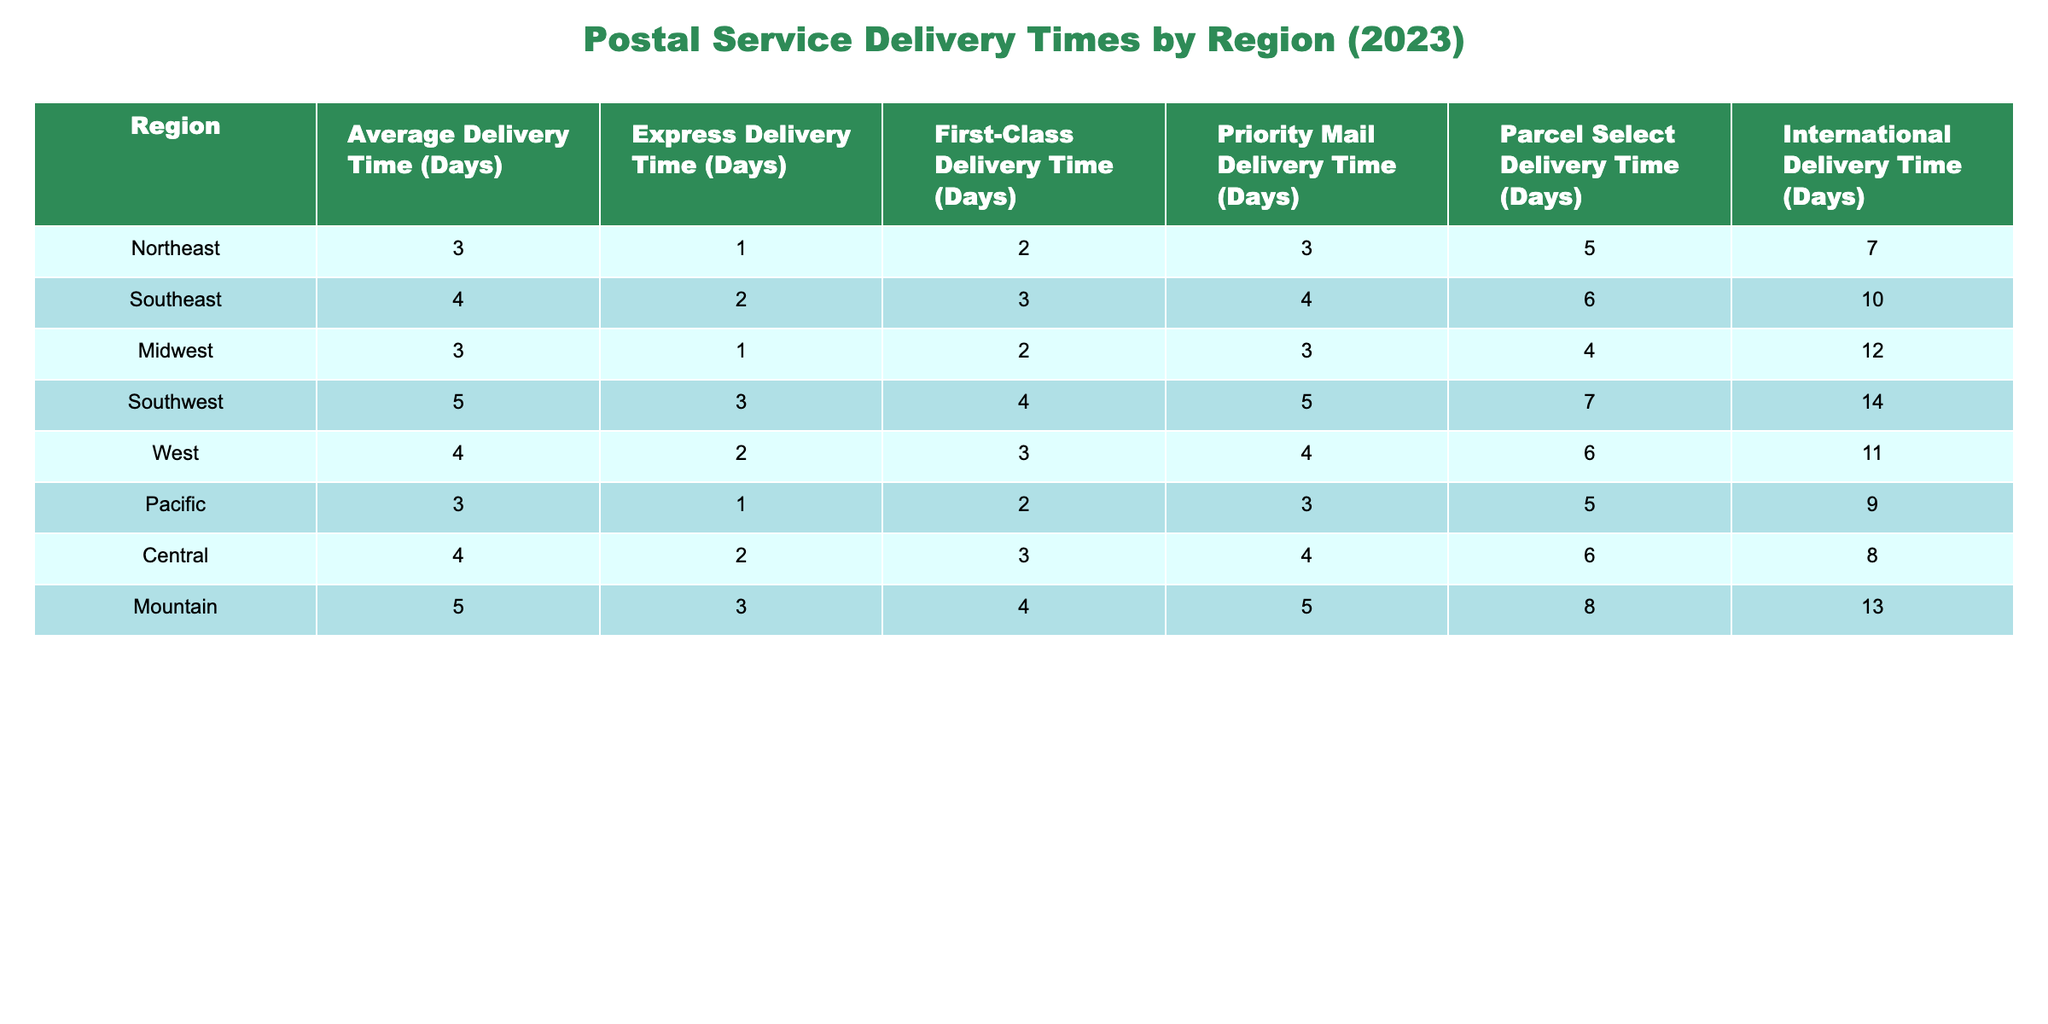What is the average delivery time in the Northeast region? The average delivery time for the Northeast region is directly found in the table under "Average Delivery Time (Days)" for that region, which is listed as 3 days.
Answer: 3 days Which region has the shortest express delivery time? To find the shortest express delivery time, we look at the "Express Delivery Time (Days)" column and identify the minimum value among the regions. The shortest time is 1 day, which occurs in three regions: Northeast, Midwest, and Pacific.
Answer: 1 day What is the difference between the average delivery time in the Southwest and the Pacific regions? The average delivery time in the Southwest is 5 days, and in the Pacific is 3 days. The difference is calculated by subtracting Pacific's time from Southwest's: 5 - 3 = 2.
Answer: 2 days Which region has the longest International delivery time and what is that time? To determine this, we check the "International Delivery Time (Days)" column for all regions and find that the Southwest region has the longest delivery time of 14 days.
Answer: Southwest has 14 days How many days is the first-class delivery time in the Southeast longer than in the Midwest? We compare their first-class delivery times: Southeast has 3 days, and Midwest has 2 days. The difference is 3 - 2 = 1 day.
Answer: 1 day Is the express delivery time in the Central region less than or equal to 2 days? Looking at the "Express Delivery Time (Days)" for the Central region, we see it is 2 days, which is equal to 2. Therefore, the statement is true.
Answer: Yes What is the average international delivery time for the Mountain and Southwest regions? The international delivery time for Mountain is 13 days, and for Southwest, it is 14 days. The average is (13 + 14) / 2 = 13.5 days.
Answer: 13.5 days Which region has greater than 10 days for both Parcel Select and International delivery times? We check both columns: the Southwest has 14 days for International, and both the Southwest and Mountain have 7 and 14 days for Parcel Select, respectively. Therefore, the Southwest region is the only region that meets this criteria.
Answer: Southwest If every region's delivery time increased by 1 day, what would the new average delivery time for all regions be? First, we sum the current average delivery times: 3 + 4 + 3 + 5 + 4 + 3 + 4 + 5 = 31. Dividing by the number of regions (8), we get an average of 31 / 8 = 3.875. After adding 1 day, the new average would be 3.875 + 1 = 4.875 days.
Answer: 4.875 days In which region do express deliveries take longer than average deliveries? We look for regions where the "Express Delivery Time (Days)" is greater than "Average Delivery Time (Days)". No region meets this criteria, as all express times are less than or equal to their corresponding average delivery times.
Answer: No region 